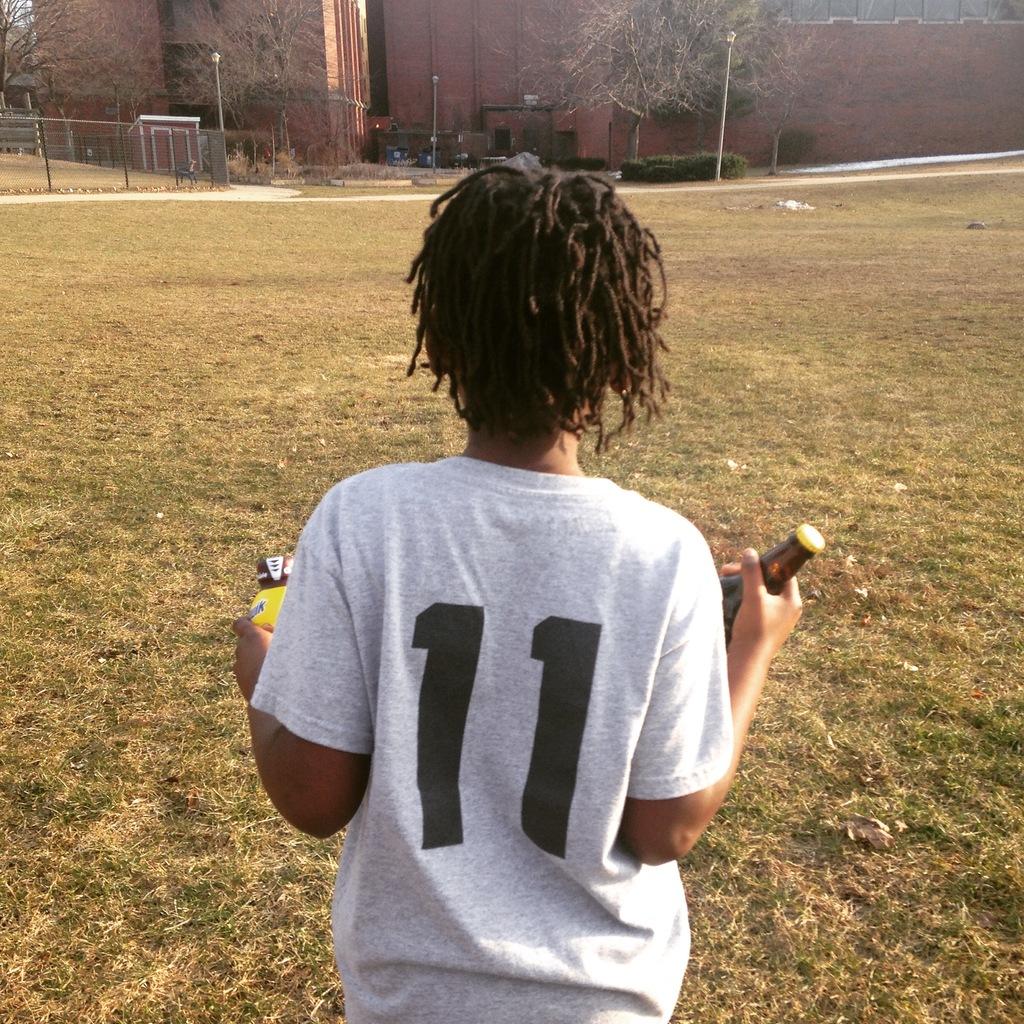11 shirt number?
Give a very brief answer. Yes. 